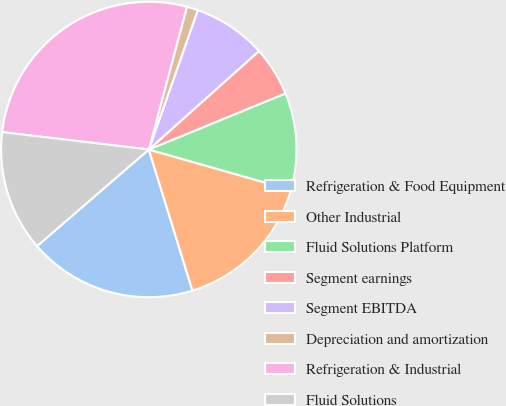<chart> <loc_0><loc_0><loc_500><loc_500><pie_chart><fcel>Refrigeration & Food Equipment<fcel>Other Industrial<fcel>Fluid Solutions Platform<fcel>Segment earnings<fcel>Segment EBITDA<fcel>Depreciation and amortization<fcel>Refrigeration & Industrial<fcel>Fluid Solutions<nl><fcel>18.43%<fcel>15.82%<fcel>10.61%<fcel>5.41%<fcel>8.01%<fcel>1.23%<fcel>27.27%<fcel>13.22%<nl></chart> 